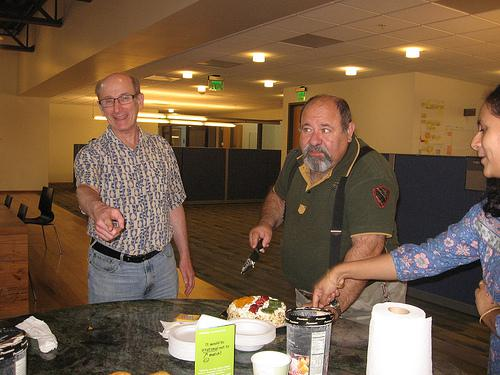Question: what is he cutting?
Choices:
A. Grass.
B. Hair.
C. Cake.
D. Pizza.
Answer with the letter. Answer: C Question: how many people?
Choices:
A. 2.
B. 4.
C. 3.
D. 5.
Answer with the letter. Answer: C Question: what is on the table?
Choices:
A. Plates.
B. Cake.
C. Glasses.
D. Tablecloth.
Answer with the letter. Answer: B 